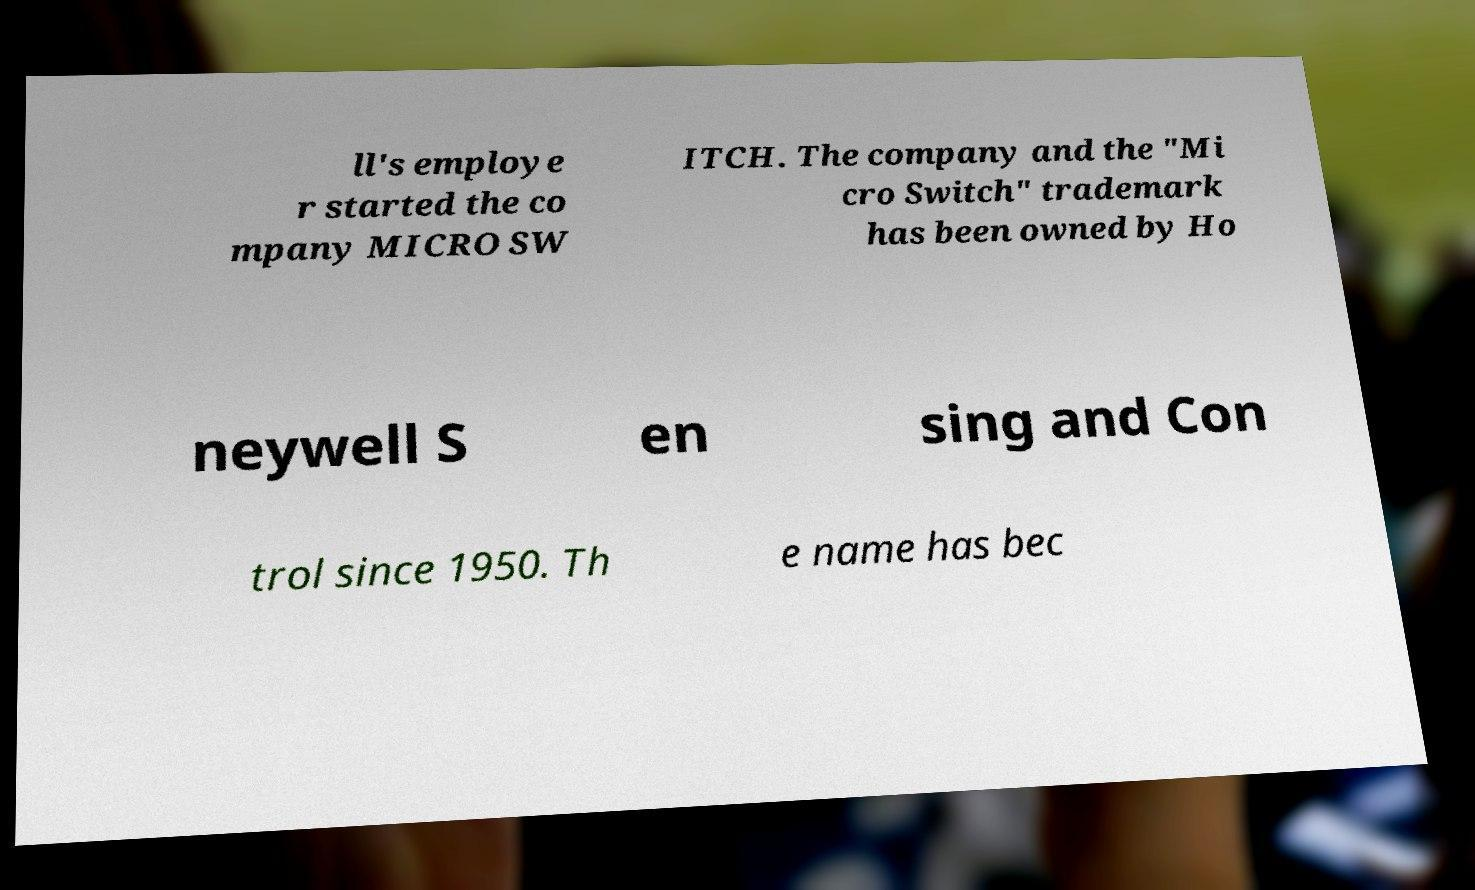For documentation purposes, I need the text within this image transcribed. Could you provide that? ll's employe r started the co mpany MICRO SW ITCH. The company and the "Mi cro Switch" trademark has been owned by Ho neywell S en sing and Con trol since 1950. Th e name has bec 